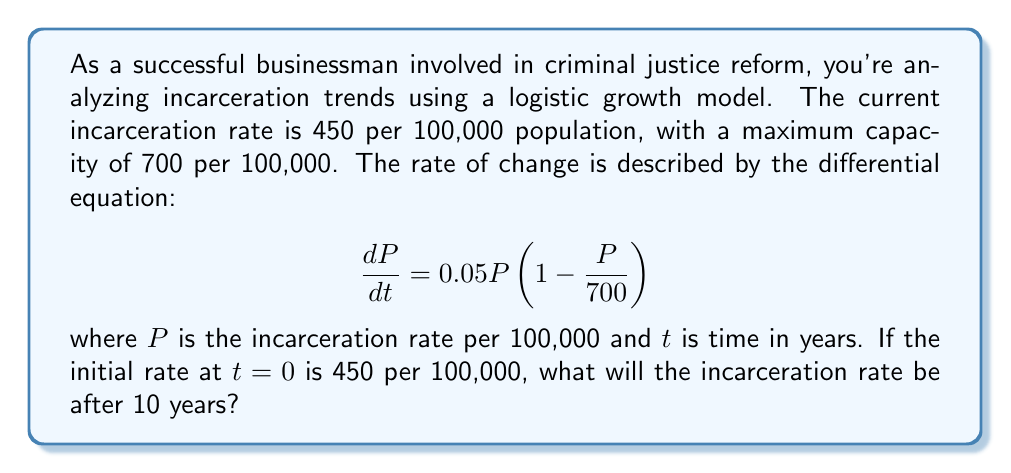Provide a solution to this math problem. To solve this problem, we need to use the logistic growth model and solve the given differential equation. The steps are as follows:

1) The general solution for the logistic growth model is:

   $$P(t) = \frac{K}{1 + Ae^{-rt}}$$

   where $K$ is the carrying capacity (maximum rate), $r$ is the growth rate, and $A$ is a constant we need to determine.

2) We're given that $K = 700$ and $r = 0.05$. We need to find $A$ using the initial condition.

3) At $t = 0$, $P(0) = 450$. Substituting this into our equation:

   $$450 = \frac{700}{1 + A}$$

4) Solving for $A$:

   $$1 + A = \frac{700}{450}$$
   $$A = \frac{700}{450} - 1 = \frac{5}{9}$$

5) Now we have our complete equation:

   $$P(t) = \frac{700}{1 + \frac{5}{9}e^{-0.05t}}$$

6) To find the rate after 10 years, we substitute $t = 10$:

   $$P(10) = \frac{700}{1 + \frac{5}{9}e^{-0.5}}$$

7) Calculating this:

   $$P(10) \approx 553.62$$

Therefore, after 10 years, the incarceration rate will be approximately 554 per 100,000 population.
Answer: 554 per 100,000 population 